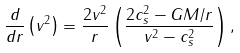<formula> <loc_0><loc_0><loc_500><loc_500>\frac { d } { d r } \left ( v ^ { 2 } \right ) = \frac { 2 v ^ { 2 } } { r } \left ( \frac { 2 c _ { s } ^ { 2 } - G M / r } { v ^ { 2 } - c _ { s } ^ { 2 } } \right ) ,</formula> 